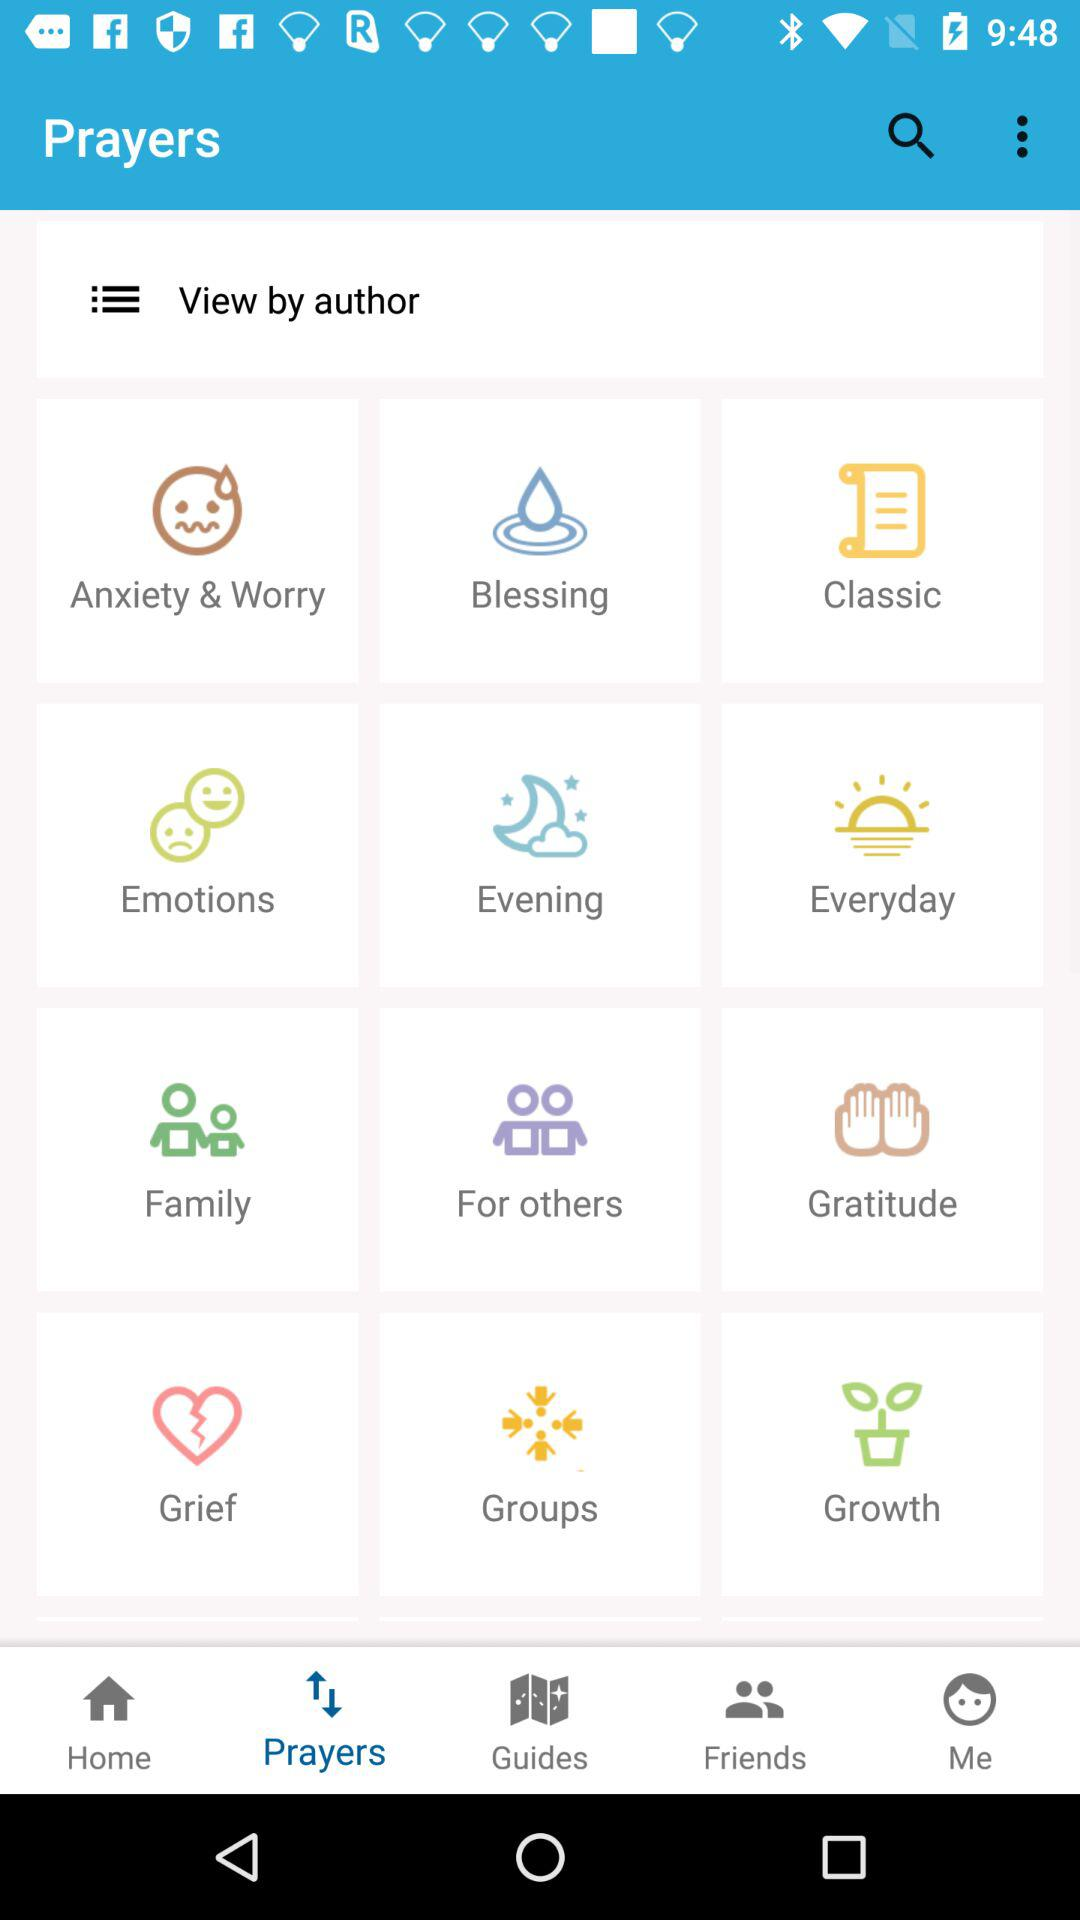Which tab is selected? The tab "Prayers" is selected. 